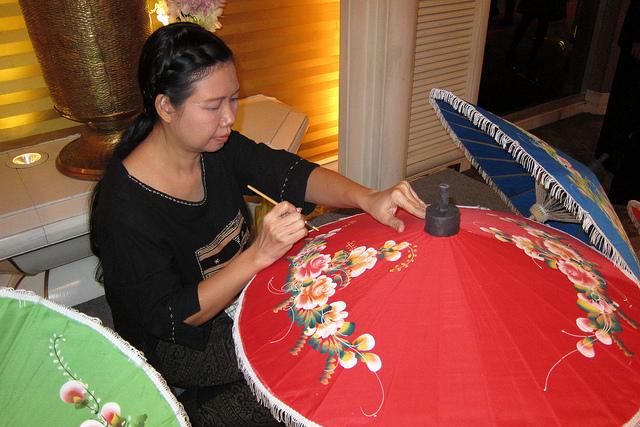Is the woman right-handed?
Give a very brief answer. Yes. Of what ethnicity does this woman appear?
Give a very brief answer. Asian. Is she asleep?
Keep it brief. No. 